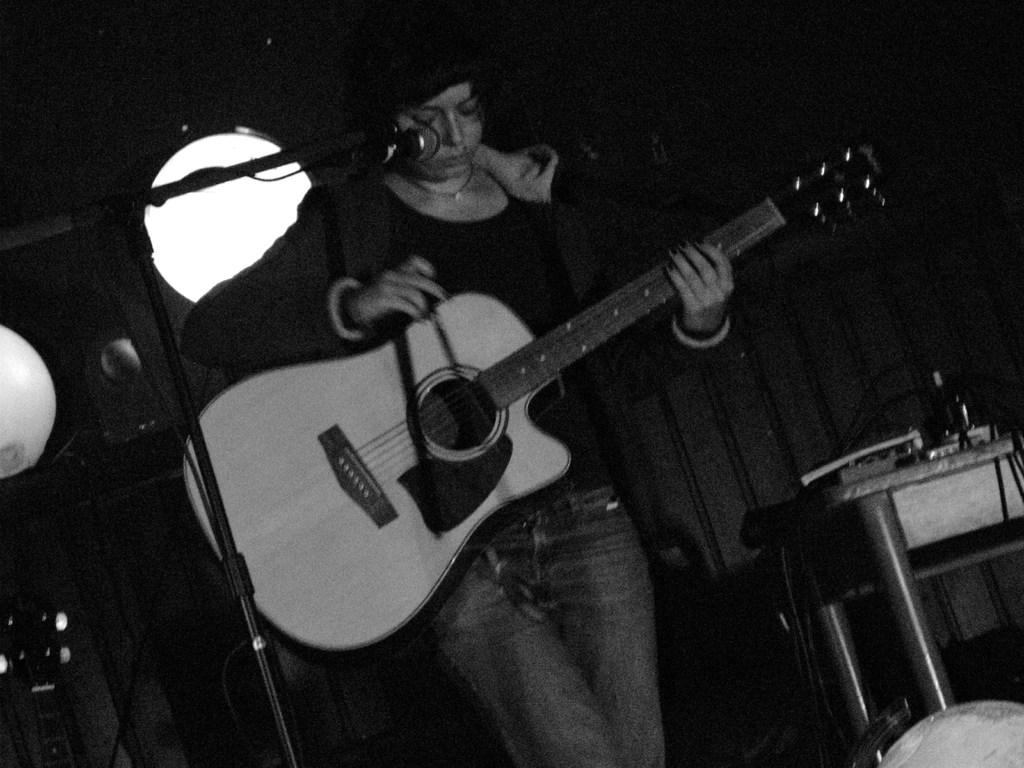What is the color scheme of the image? The image is black and white. What is the person in the image doing? The person is playing a guitar. What can be seen near the person in the image? There is a microphone with a microphone stand in the image. What else is present in the image besides the person and the microphone? There is a table with objects on it in the image. How much lettuce is visible on the table in the image? There is no lettuce visible on the table in the image. 